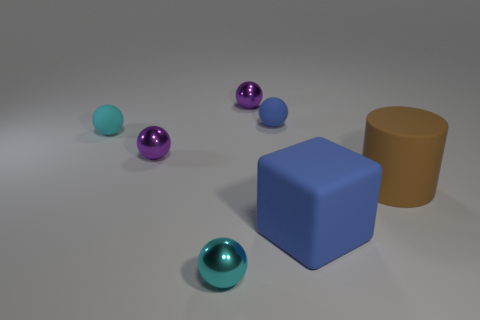Can you tell me the colors of the round objects on the right? Certainly, there are three round objects on the right side of the image. From front to back, their colors are purple, teal, and blue. 